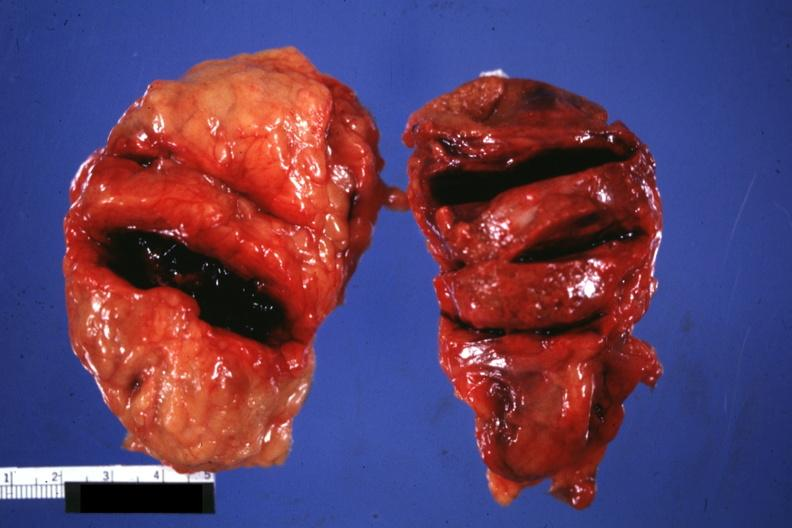what is obvious?
Answer the question using a single word or phrase. External view of gland with knife cuts into parenchyma hemorrhage 